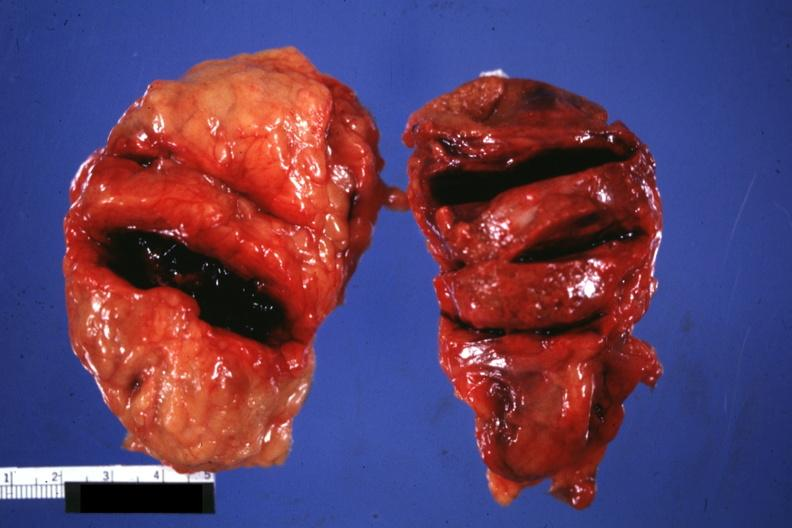what is obvious?
Answer the question using a single word or phrase. External view of gland with knife cuts into parenchyma hemorrhage 